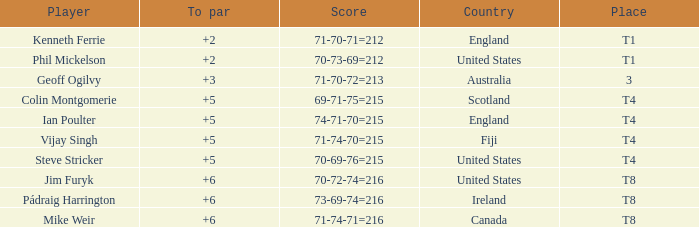What score to par did Mike Weir have? 6.0. Would you be able to parse every entry in this table? {'header': ['Player', 'To par', 'Score', 'Country', 'Place'], 'rows': [['Kenneth Ferrie', '+2', '71-70-71=212', 'England', 'T1'], ['Phil Mickelson', '+2', '70-73-69=212', 'United States', 'T1'], ['Geoff Ogilvy', '+3', '71-70-72=213', 'Australia', '3'], ['Colin Montgomerie', '+5', '69-71-75=215', 'Scotland', 'T4'], ['Ian Poulter', '+5', '74-71-70=215', 'England', 'T4'], ['Vijay Singh', '+5', '71-74-70=215', 'Fiji', 'T4'], ['Steve Stricker', '+5', '70-69-76=215', 'United States', 'T4'], ['Jim Furyk', '+6', '70-72-74=216', 'United States', 'T8'], ['Pádraig Harrington', '+6', '73-69-74=216', 'Ireland', 'T8'], ['Mike Weir', '+6', '71-74-71=216', 'Canada', 'T8']]} 